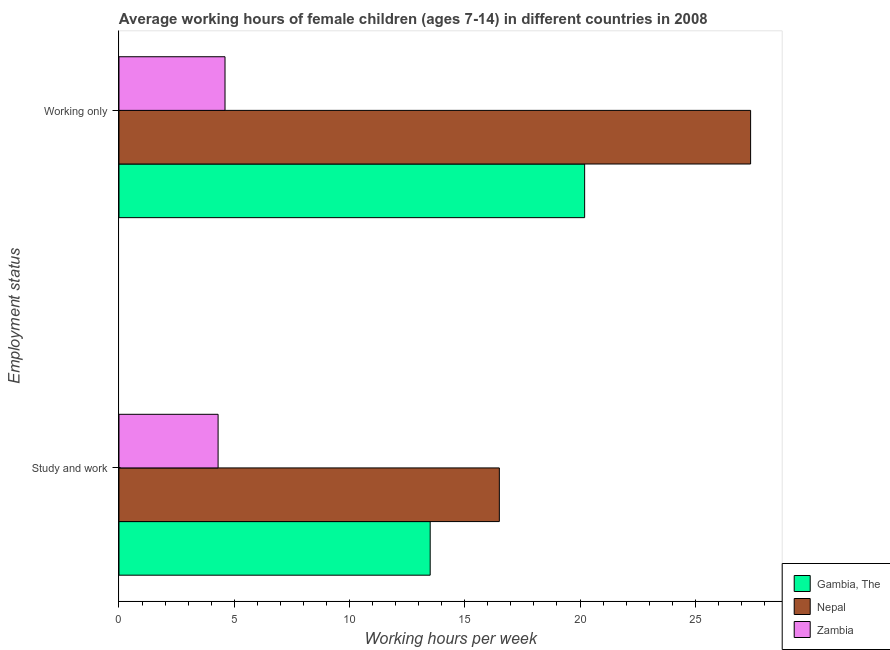What is the label of the 2nd group of bars from the top?
Keep it short and to the point. Study and work. What is the average working hour of children involved in study and work in Zambia?
Make the answer very short. 4.3. Across all countries, what is the maximum average working hour of children involved in study and work?
Keep it short and to the point. 16.5. Across all countries, what is the minimum average working hour of children involved in only work?
Provide a succinct answer. 4.6. In which country was the average working hour of children involved in only work maximum?
Provide a short and direct response. Nepal. In which country was the average working hour of children involved in only work minimum?
Your answer should be very brief. Zambia. What is the total average working hour of children involved in only work in the graph?
Keep it short and to the point. 52.2. What is the difference between the average working hour of children involved in only work in Zambia and that in Nepal?
Keep it short and to the point. -22.8. What is the difference between the average working hour of children involved in study and work in Gambia, The and the average working hour of children involved in only work in Zambia?
Offer a very short reply. 8.9. What is the difference between the average working hour of children involved in study and work and average working hour of children involved in only work in Gambia, The?
Make the answer very short. -6.7. What is the ratio of the average working hour of children involved in study and work in Nepal to that in Gambia, The?
Offer a very short reply. 1.22. In how many countries, is the average working hour of children involved in only work greater than the average average working hour of children involved in only work taken over all countries?
Offer a very short reply. 2. What does the 3rd bar from the top in Study and work represents?
Give a very brief answer. Gambia, The. What does the 2nd bar from the bottom in Working only represents?
Provide a succinct answer. Nepal. How many countries are there in the graph?
Keep it short and to the point. 3. What is the difference between two consecutive major ticks on the X-axis?
Offer a very short reply. 5. How are the legend labels stacked?
Ensure brevity in your answer.  Vertical. What is the title of the graph?
Offer a very short reply. Average working hours of female children (ages 7-14) in different countries in 2008. What is the label or title of the X-axis?
Offer a terse response. Working hours per week. What is the label or title of the Y-axis?
Provide a succinct answer. Employment status. What is the Working hours per week of Gambia, The in Study and work?
Provide a succinct answer. 13.5. What is the Working hours per week of Gambia, The in Working only?
Provide a short and direct response. 20.2. What is the Working hours per week of Nepal in Working only?
Your response must be concise. 27.4. What is the Working hours per week of Zambia in Working only?
Ensure brevity in your answer.  4.6. Across all Employment status, what is the maximum Working hours per week in Gambia, The?
Provide a succinct answer. 20.2. Across all Employment status, what is the maximum Working hours per week of Nepal?
Provide a succinct answer. 27.4. Across all Employment status, what is the maximum Working hours per week of Zambia?
Offer a terse response. 4.6. Across all Employment status, what is the minimum Working hours per week in Gambia, The?
Your answer should be compact. 13.5. What is the total Working hours per week in Gambia, The in the graph?
Provide a succinct answer. 33.7. What is the total Working hours per week of Nepal in the graph?
Provide a succinct answer. 43.9. What is the difference between the Working hours per week in Gambia, The in Study and work and that in Working only?
Offer a very short reply. -6.7. What is the difference between the Working hours per week of Nepal in Study and work and that in Working only?
Provide a short and direct response. -10.9. What is the difference between the Working hours per week in Gambia, The in Study and work and the Working hours per week in Nepal in Working only?
Give a very brief answer. -13.9. What is the difference between the Working hours per week of Gambia, The in Study and work and the Working hours per week of Zambia in Working only?
Ensure brevity in your answer.  8.9. What is the average Working hours per week in Gambia, The per Employment status?
Ensure brevity in your answer.  16.85. What is the average Working hours per week in Nepal per Employment status?
Your answer should be very brief. 21.95. What is the average Working hours per week of Zambia per Employment status?
Offer a very short reply. 4.45. What is the difference between the Working hours per week in Gambia, The and Working hours per week in Nepal in Study and work?
Provide a short and direct response. -3. What is the difference between the Working hours per week in Gambia, The and Working hours per week in Zambia in Study and work?
Your response must be concise. 9.2. What is the difference between the Working hours per week in Gambia, The and Working hours per week in Zambia in Working only?
Offer a terse response. 15.6. What is the difference between the Working hours per week in Nepal and Working hours per week in Zambia in Working only?
Your answer should be compact. 22.8. What is the ratio of the Working hours per week of Gambia, The in Study and work to that in Working only?
Offer a terse response. 0.67. What is the ratio of the Working hours per week of Nepal in Study and work to that in Working only?
Ensure brevity in your answer.  0.6. What is the ratio of the Working hours per week of Zambia in Study and work to that in Working only?
Provide a succinct answer. 0.93. What is the difference between the highest and the second highest Working hours per week of Gambia, The?
Offer a very short reply. 6.7. What is the difference between the highest and the second highest Working hours per week of Zambia?
Keep it short and to the point. 0.3. What is the difference between the highest and the lowest Working hours per week in Gambia, The?
Provide a short and direct response. 6.7. 